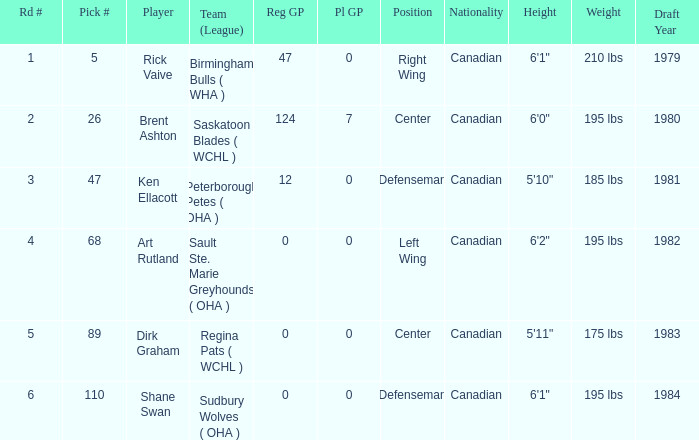Write the full table. {'header': ['Rd #', 'Pick #', 'Player', 'Team (League)', 'Reg GP', 'Pl GP', 'Position', 'Nationality', 'Height', 'Weight', 'Draft Year'], 'rows': [['1', '5', 'Rick Vaive', 'Birmingham Bulls ( WHA )', '47', '0', 'Right Wing', 'Canadian', '6\'1"', '210 lbs', '1979'], ['2', '26', 'Brent Ashton', 'Saskatoon Blades ( WCHL )', '124', '7', 'Center', 'Canadian', '6\'0"', '195 lbs', '1980'], ['3', '47', 'Ken Ellacott', 'Peterborough Petes ( OHA )', '12', '0', 'Defenseman', 'Canadian', '5\'10"', '185 lbs', '1981'], ['4', '68', 'Art Rutland', 'Sault Ste. Marie Greyhounds ( OHA )', '0', '0', 'Left Wing', 'Canadian', '6\'2"', '195 lbs', '1982'], ['5', '89', 'Dirk Graham', 'Regina Pats ( WCHL )', '0', '0', 'Center', 'Canadian', '5\'11"', '175 lbs', '1983'], ['6', '110', 'Shane Swan', 'Sudbury Wolves ( OHA )', '0', '0', 'Defenseman', 'Canadian', '6\'1"', '195 lbs', '1984']]} How many reg GP for rick vaive in round 1? None. 